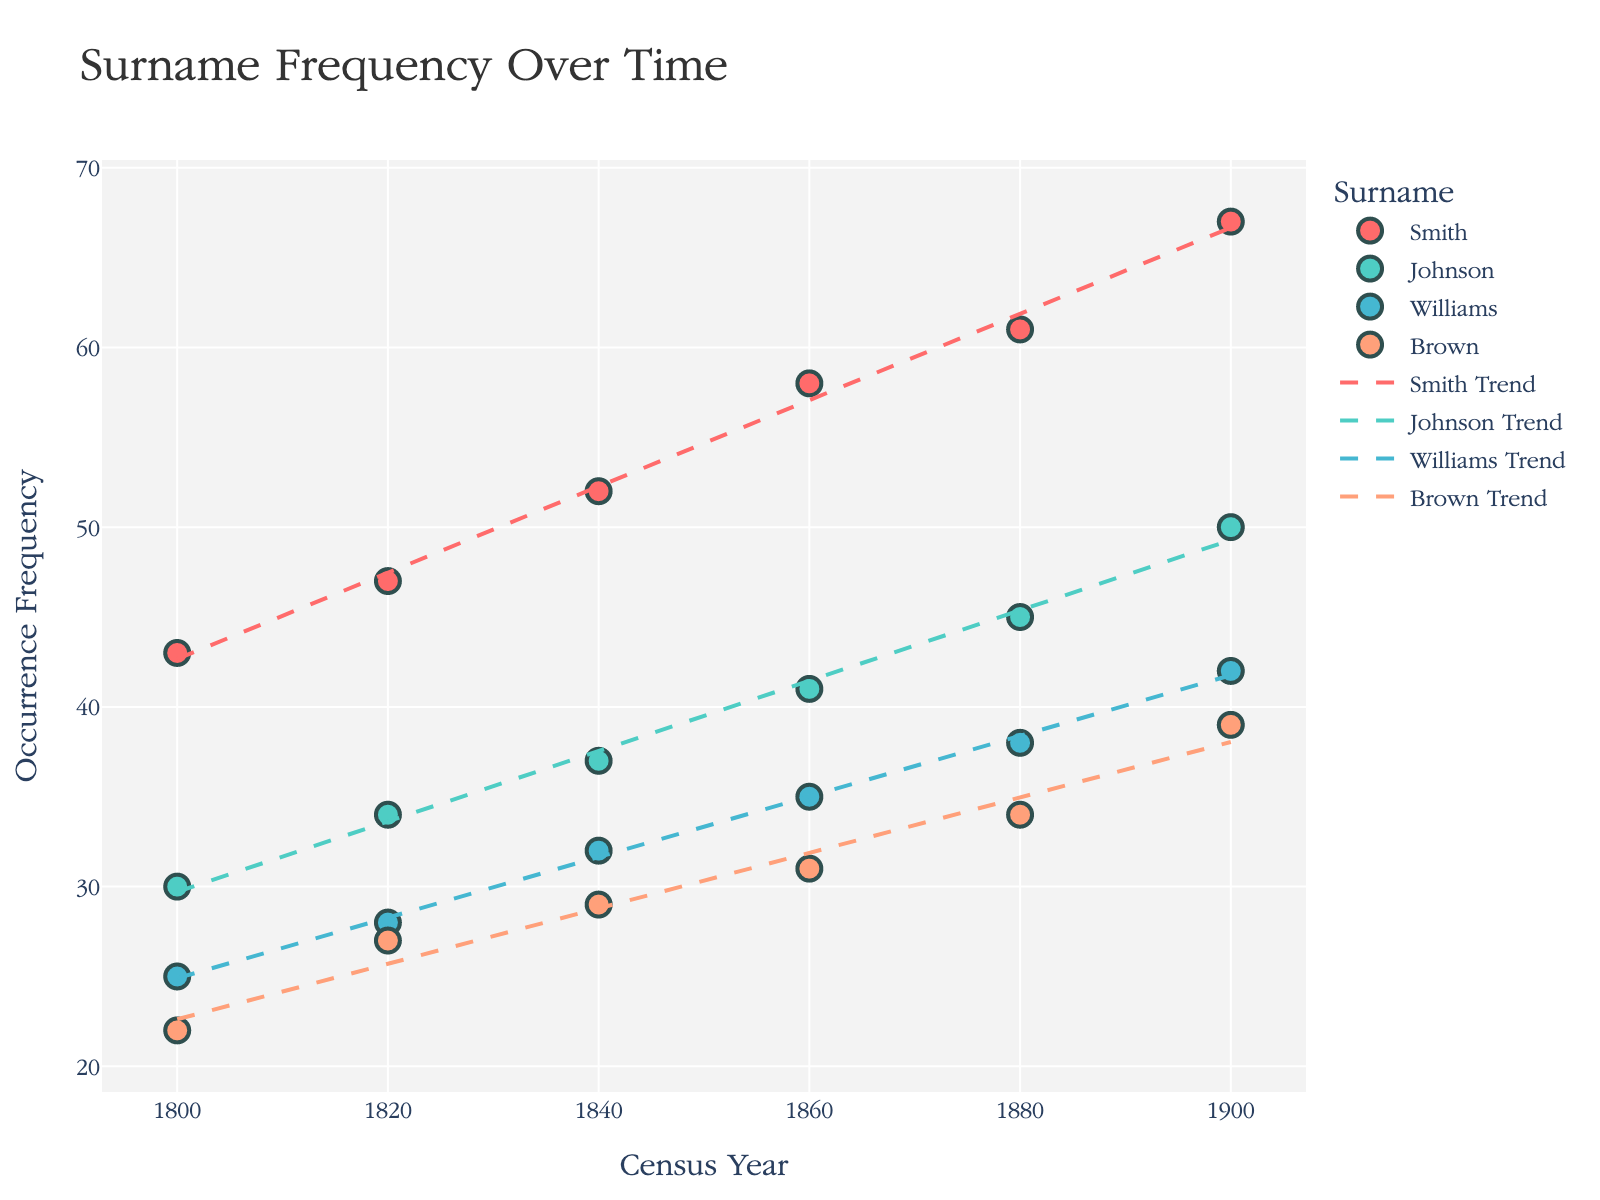What's the title of the plot? The title of the plot is displayed at the top and typically summarizes the primary information shown in the figure. Here, it's directly visible.
Answer: Surname Frequency Over Time What does the y-axis represent? The y-axis label is displayed on the vertical axis and shows what metrics or data points are being plotted against. In this case, it's labeled "Occurrence Frequency."
Answer: Occurrence Frequency Which surname has the highest frequency in the year 1900? Look at the data points along the year 1900 on the x-axis and identify the highest y-value. The surname with this highest value in 1900 is "Smith."
Answer: Smith What is the trend for the surname "Brown" over time? Look at both the scatter plot points and the trend line representing the surname "Brown" across different years. The trend shows a steady increase in frequency from 1800 to 1900.
Answer: Increasing trend How many surnames are represented in the plot? Count the distinct color-coded clusters or the legend entries. There are four surnames represented: Smith, Johnson, Williams, and Brown.
Answer: Four Which surname showed the least increase in frequency from 1800 to 1900? Calculate the change in frequency for each surname from the 1800 data point to the 1900 data point. The surname "Brown" has the least increase: 17 (from 22 to 39).
Answer: Brown Between which two decades did "Smith" experience its greatest increase in frequency? Calculate the increase in frequency for each two-decade period for "Smith" and identify the period with the highest increase. The greatest increase (10) occurs between 1840 (52) and 1860 (58).
Answer: 1840 to 1860 Comparing "Johnson" and "Williams," which surname started at a lower frequency and ended at a higher frequency? Check their frequencies in the year 1800 and 1900. "Williams" started lower (25 vs. 30) and ended higher (42 vs. 50) than "Johnson."
Answer: Williams started lower, Johnson ended higher Which surname had a different colored trend line with a dash pattern? Trend lines with dashed patterns can be observed for each surname. Identify the surname matching this description by pointing to the legend or visual inspection. Everyone's trend line has a dash pattern unique to itself, but "Smith" is one specific example among them.
Answer: Smith What's the average frequency change per decade for "Johnson"? Calculate the total change in frequency from 1800 to 1900 for "Johnson" which is 20 (50-30). Divide this change by the number of decades (10), giving an average change per decade. Total change = (30 to 50) = 20 / 10 = 2
Answer: 2 